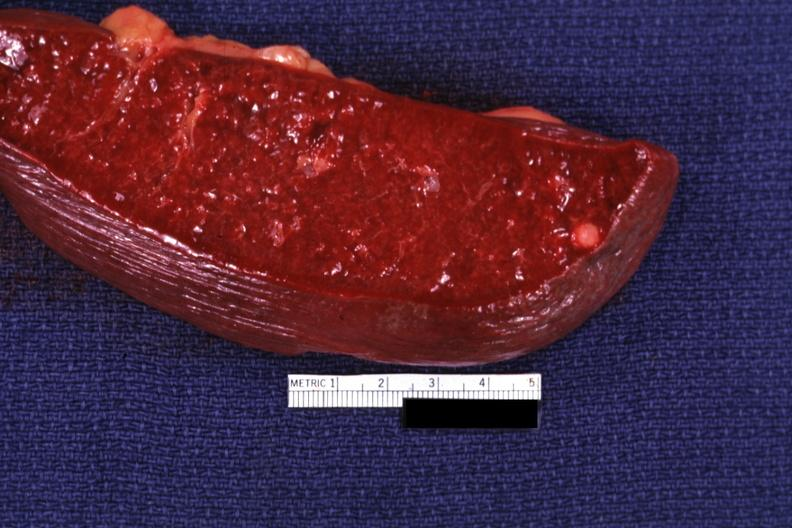how does this image show cut surface?
Answer the question using a single word or phrase. With typical healed granuloma 